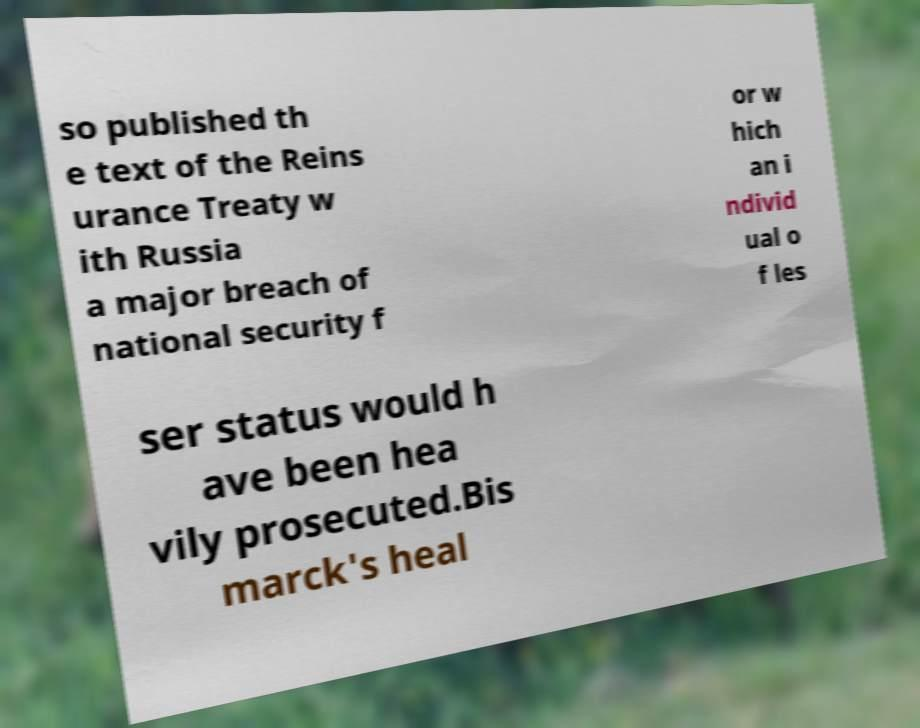Please read and relay the text visible in this image. What does it say? so published th e text of the Reins urance Treaty w ith Russia a major breach of national security f or w hich an i ndivid ual o f les ser status would h ave been hea vily prosecuted.Bis marck's heal 